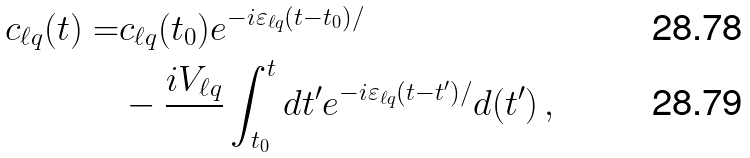Convert formula to latex. <formula><loc_0><loc_0><loc_500><loc_500>c _ { \ell q } ( t ) = & c _ { \ell q } ( t _ { 0 } ) e ^ { - i \varepsilon _ { \ell q } ( t - t _ { 0 } ) / } \\ & - \frac { i V _ { \ell q } } { } \int _ { t _ { 0 } } ^ { t } d t ^ { \prime } e ^ { - i \varepsilon _ { \ell q } ( t - t ^ { \prime } ) / } d ( t ^ { \prime } ) \, ,</formula> 